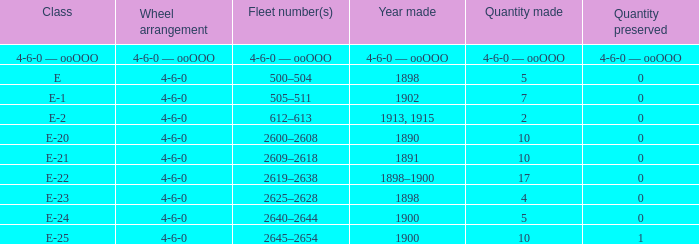How many e-22 class items are made when the preserved quantity is 0? 17.0. Parse the full table. {'header': ['Class', 'Wheel arrangement', 'Fleet number(s)', 'Year made', 'Quantity made', 'Quantity preserved'], 'rows': [['4-6-0 — ooOOO', '4-6-0 — ooOOO', '4-6-0 — ooOOO', '4-6-0 — ooOOO', '4-6-0 — ooOOO', '4-6-0 — ooOOO'], ['E', '4-6-0', '500–504', '1898', '5', '0'], ['E-1', '4-6-0', '505–511', '1902', '7', '0'], ['E-2', '4-6-0', '612–613', '1913, 1915', '2', '0'], ['E-20', '4-6-0', '2600–2608', '1890', '10', '0'], ['E-21', '4-6-0', '2609–2618', '1891', '10', '0'], ['E-22', '4-6-0', '2619–2638', '1898–1900', '17', '0'], ['E-23', '4-6-0', '2625–2628', '1898', '4', '0'], ['E-24', '4-6-0', '2640–2644', '1900', '5', '0'], ['E-25', '4-6-0', '2645–2654', '1900', '10', '1']]} 